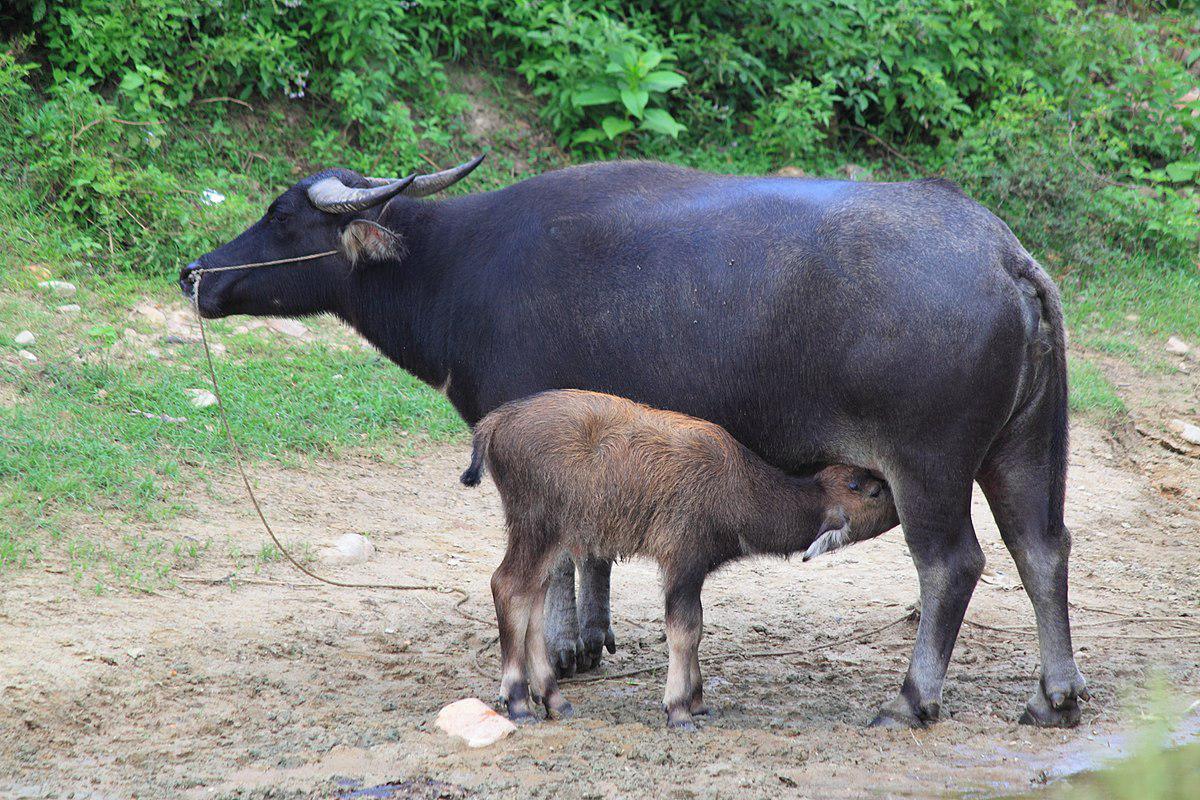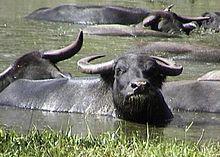The first image is the image on the left, the second image is the image on the right. For the images shown, is this caption "There is an animal that is not an ox in at least one image." true? Answer yes or no. No. 